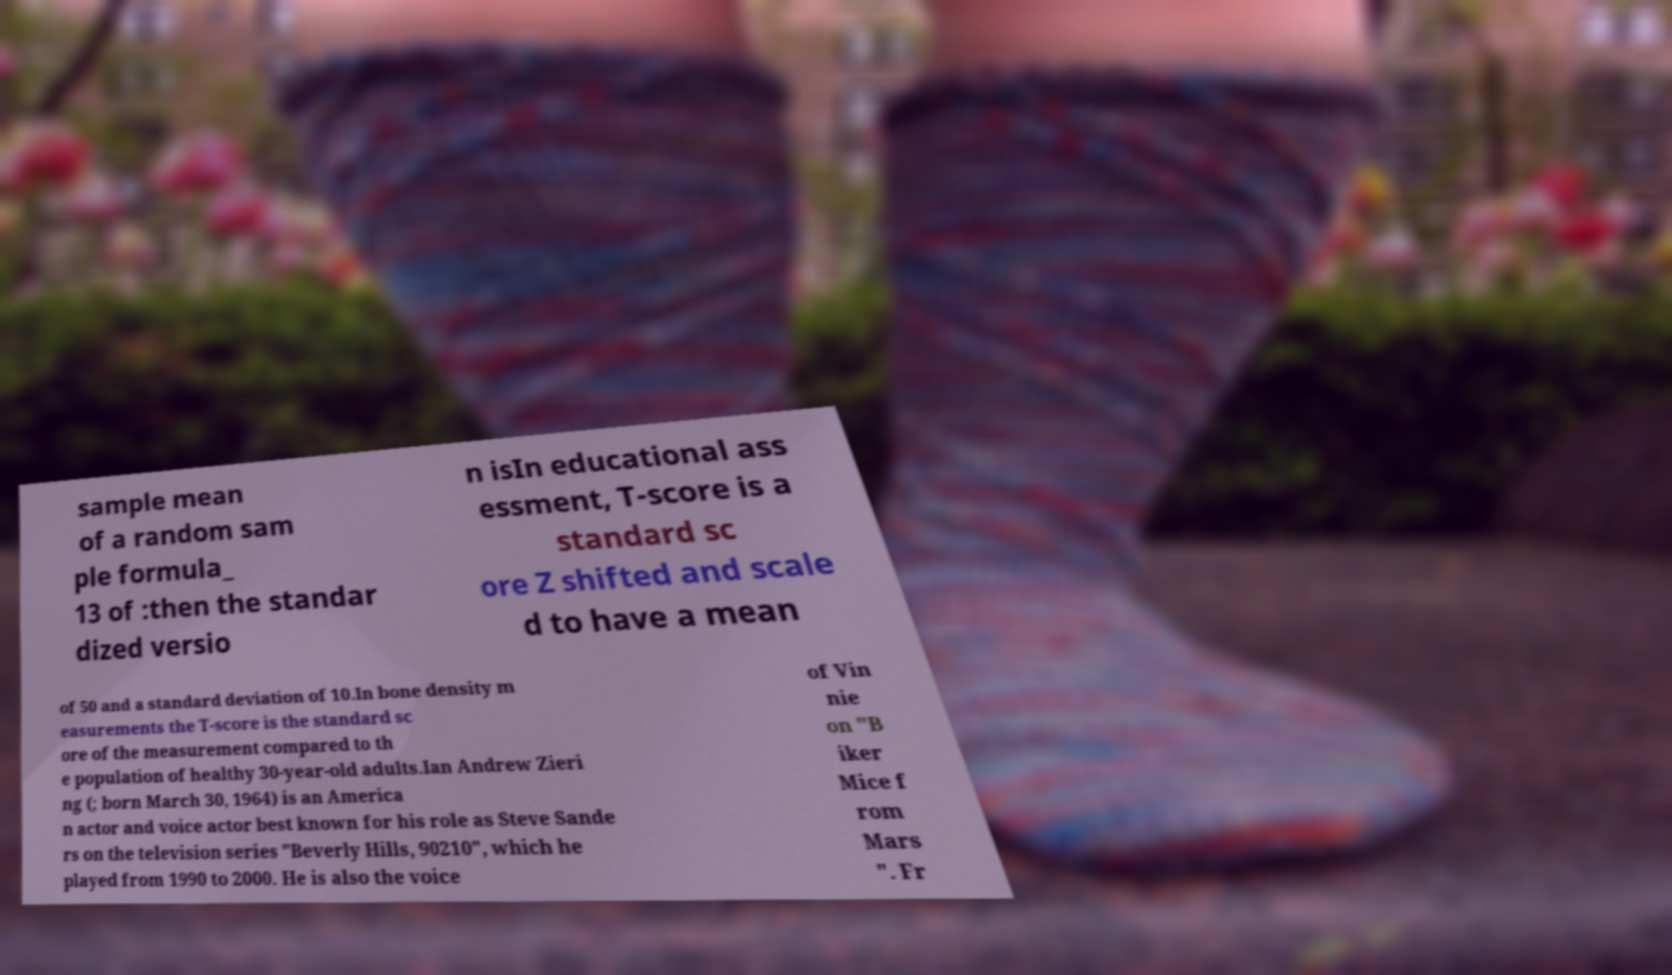Can you accurately transcribe the text from the provided image for me? sample mean of a random sam ple formula_ 13 of :then the standar dized versio n isIn educational ass essment, T-score is a standard sc ore Z shifted and scale d to have a mean of 50 and a standard deviation of 10.In bone density m easurements the T-score is the standard sc ore of the measurement compared to th e population of healthy 30-year-old adults.Ian Andrew Zieri ng (; born March 30, 1964) is an America n actor and voice actor best known for his role as Steve Sande rs on the television series "Beverly Hills, 90210", which he played from 1990 to 2000. He is also the voice of Vin nie on "B iker Mice f rom Mars ". Fr 